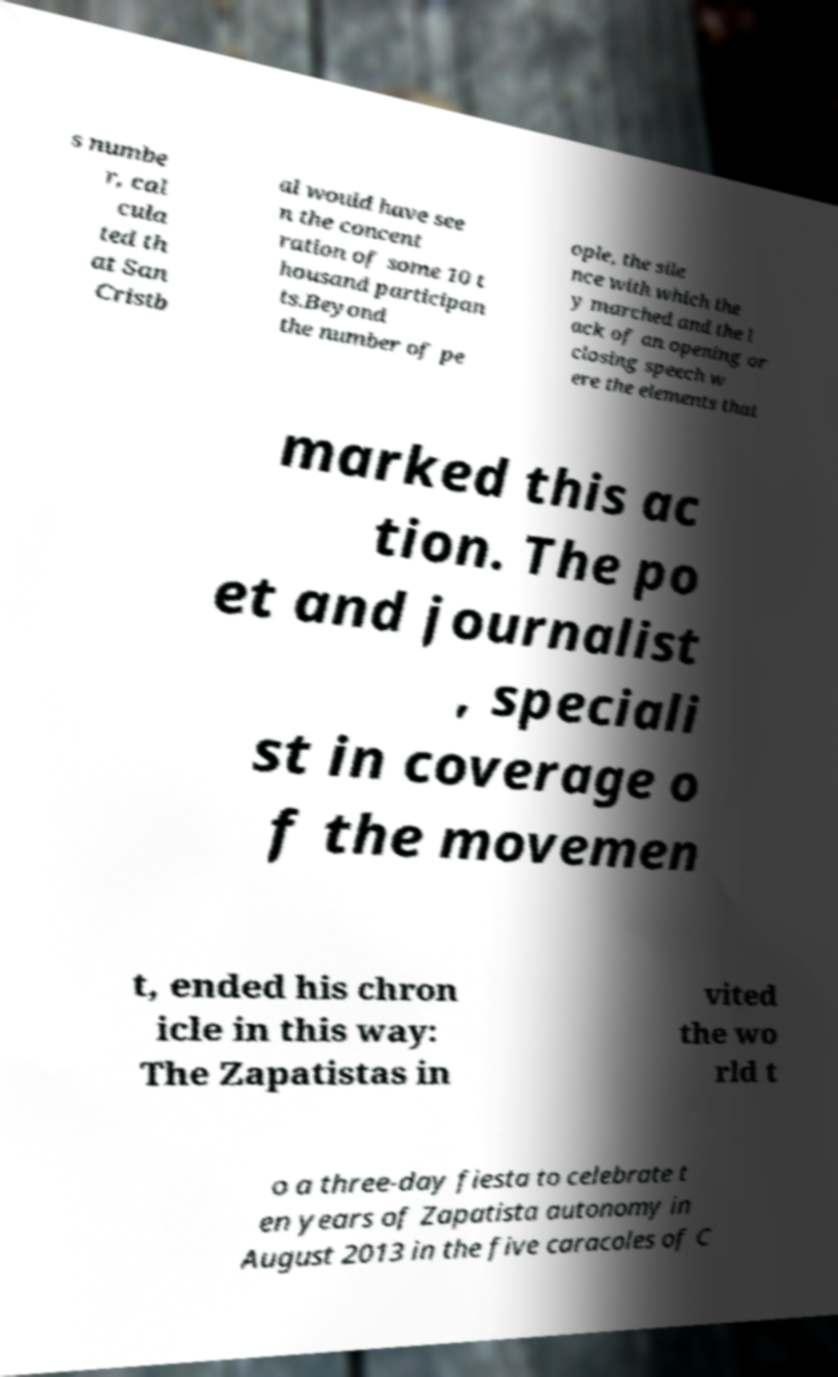For documentation purposes, I need the text within this image transcribed. Could you provide that? s numbe r, cal cula ted th at San Cristb al would have see n the concent ration of some 10 t housand participan ts.Beyond the number of pe ople, the sile nce with which the y marched and the l ack of an opening or closing speech w ere the elements that marked this ac tion. The po et and journalist , speciali st in coverage o f the movemen t, ended his chron icle in this way: The Zapatistas in vited the wo rld t o a three-day fiesta to celebrate t en years of Zapatista autonomy in August 2013 in the five caracoles of C 